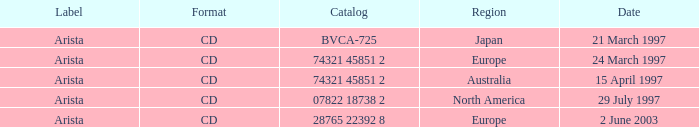What Date has the Region Europe and a Catalog of 74321 45851 2? 24 March 1997. 